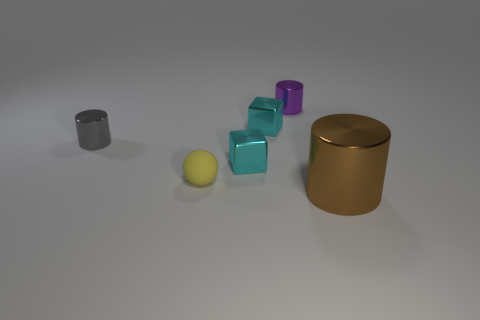Imagine these objects are part of a storytelling exercise. Can you create a short narrative that includes them? In a world where colors represent different elements of nature, the purple cube embodies the calm of dusk, the teal, the fluidity of water, and the brown cubes, the steadfastness of earth. The large gold cylinder is the vault of knowledge, securing the balance of the world. The gray and silver cylinders are the pillars of wisdom, guardians of the realm. Together, these objects symbolize harmony and are vital to the world's storytelling rituals, each unveiling a chapter of the cosmic dance between day and night, water and earth. 